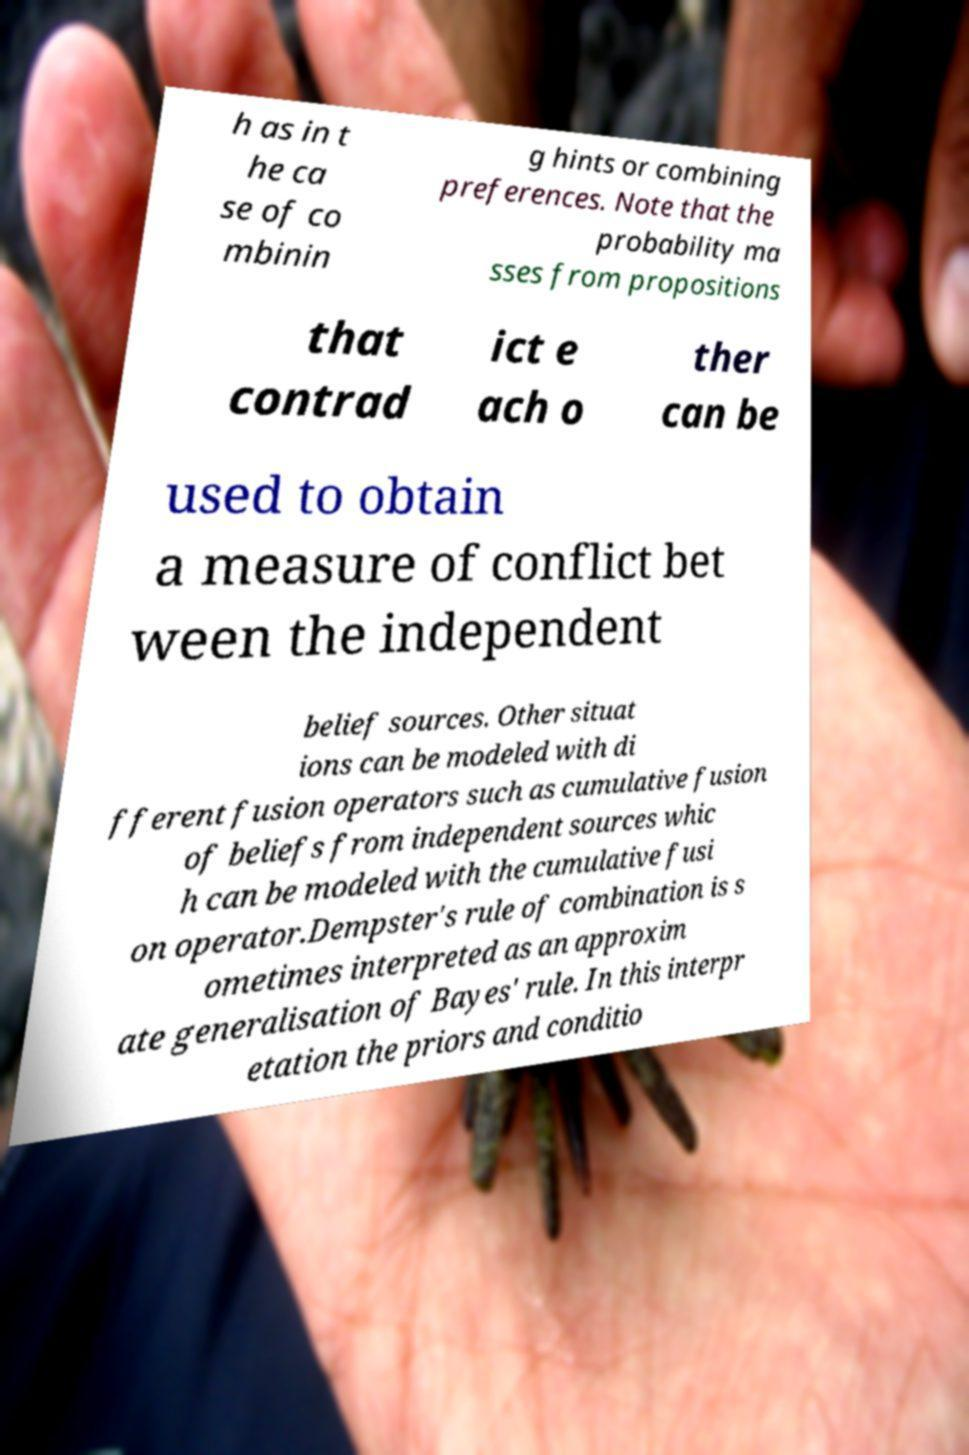Can you read and provide the text displayed in the image?This photo seems to have some interesting text. Can you extract and type it out for me? h as in t he ca se of co mbinin g hints or combining preferences. Note that the probability ma sses from propositions that contrad ict e ach o ther can be used to obtain a measure of conflict bet ween the independent belief sources. Other situat ions can be modeled with di fferent fusion operators such as cumulative fusion of beliefs from independent sources whic h can be modeled with the cumulative fusi on operator.Dempster's rule of combination is s ometimes interpreted as an approxim ate generalisation of Bayes' rule. In this interpr etation the priors and conditio 